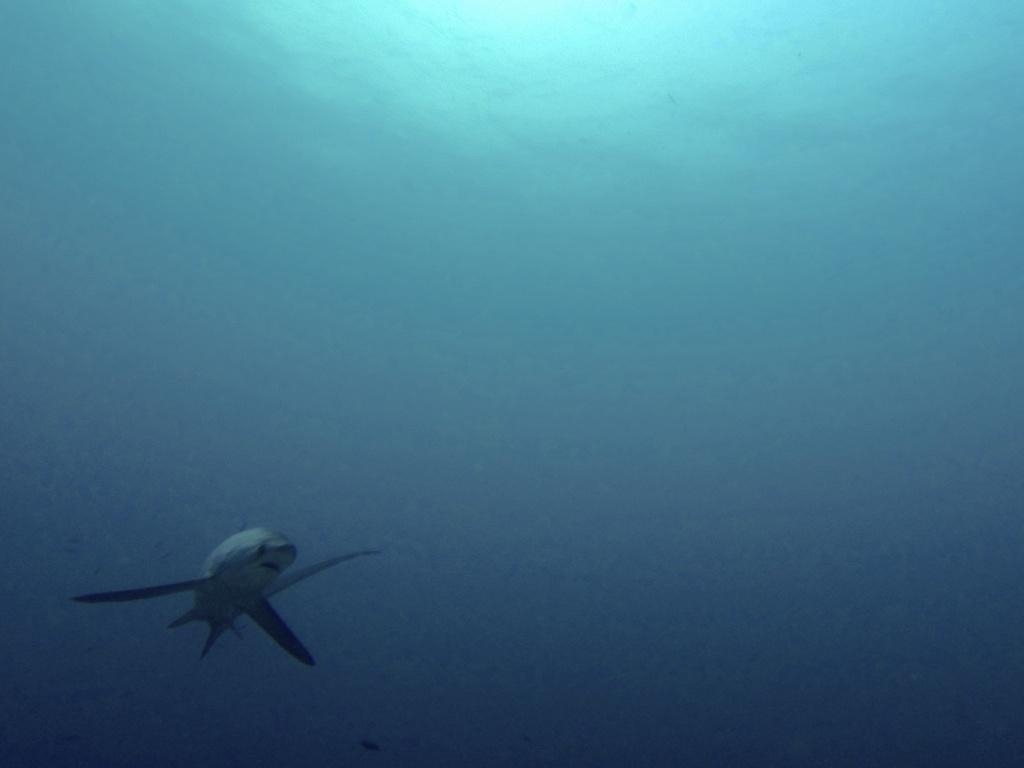What is the main subject of the image? The main subject of the image is a shark. Where is the shark located? The shark is in the sea. Can you tell me how many grapes are on the board in the image? There is no board or grapes present in the image; it features a shark in the sea. 